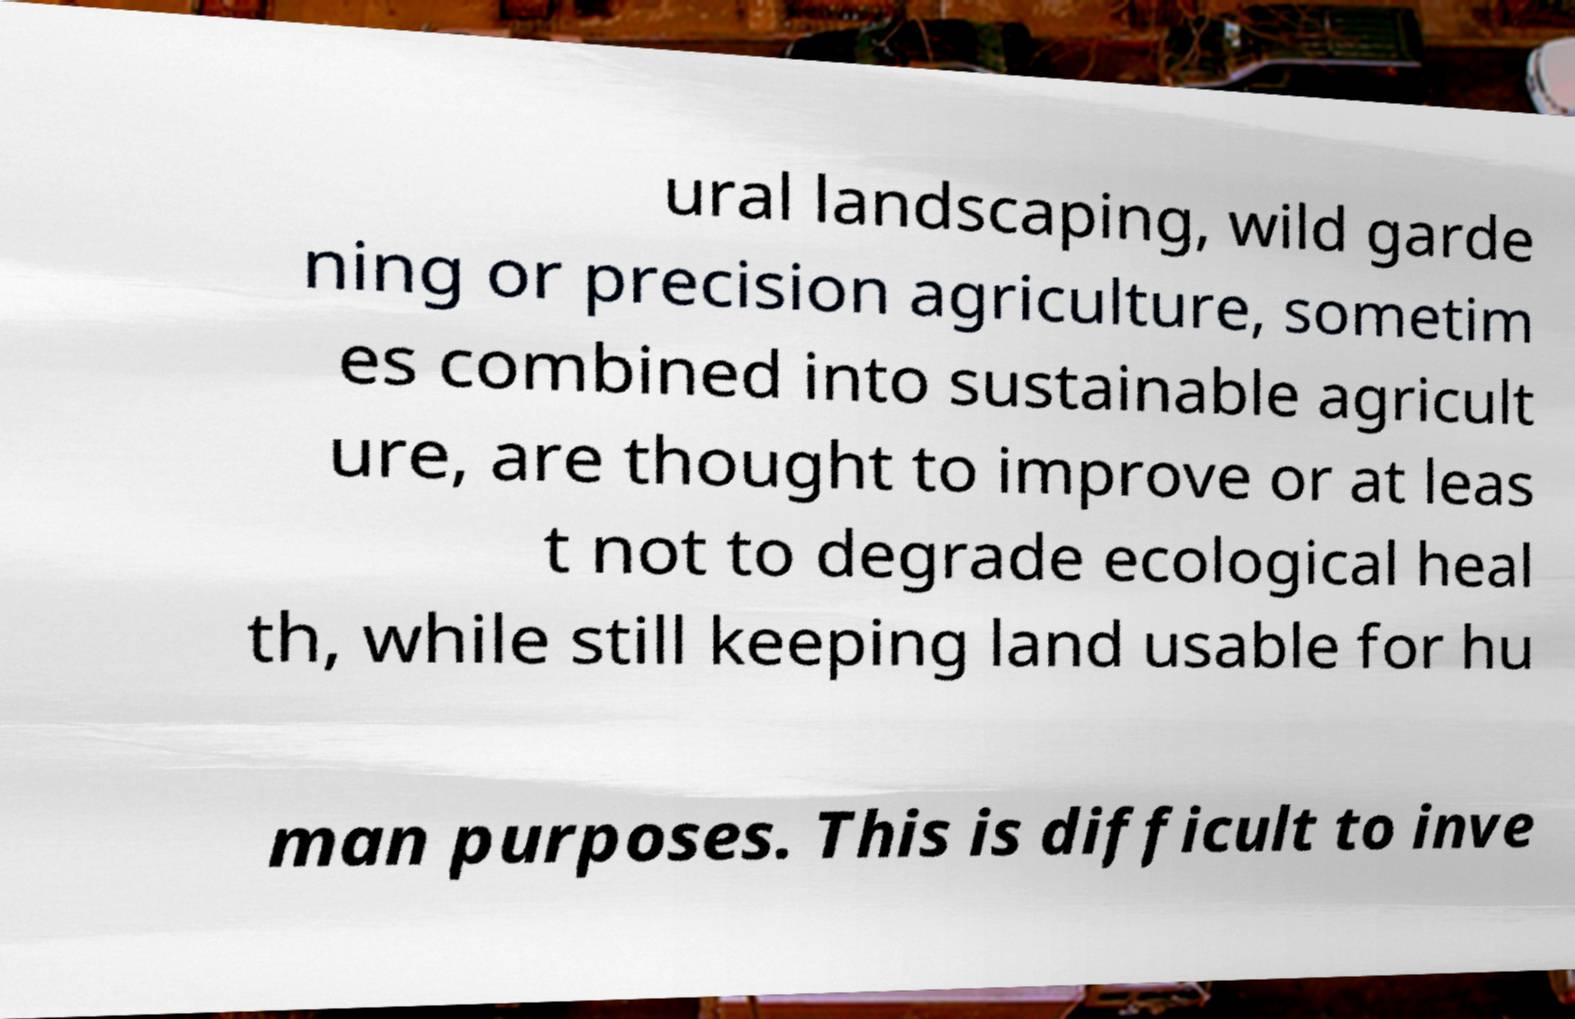For documentation purposes, I need the text within this image transcribed. Could you provide that? ural landscaping, wild garde ning or precision agriculture, sometim es combined into sustainable agricult ure, are thought to improve or at leas t not to degrade ecological heal th, while still keeping land usable for hu man purposes. This is difficult to inve 